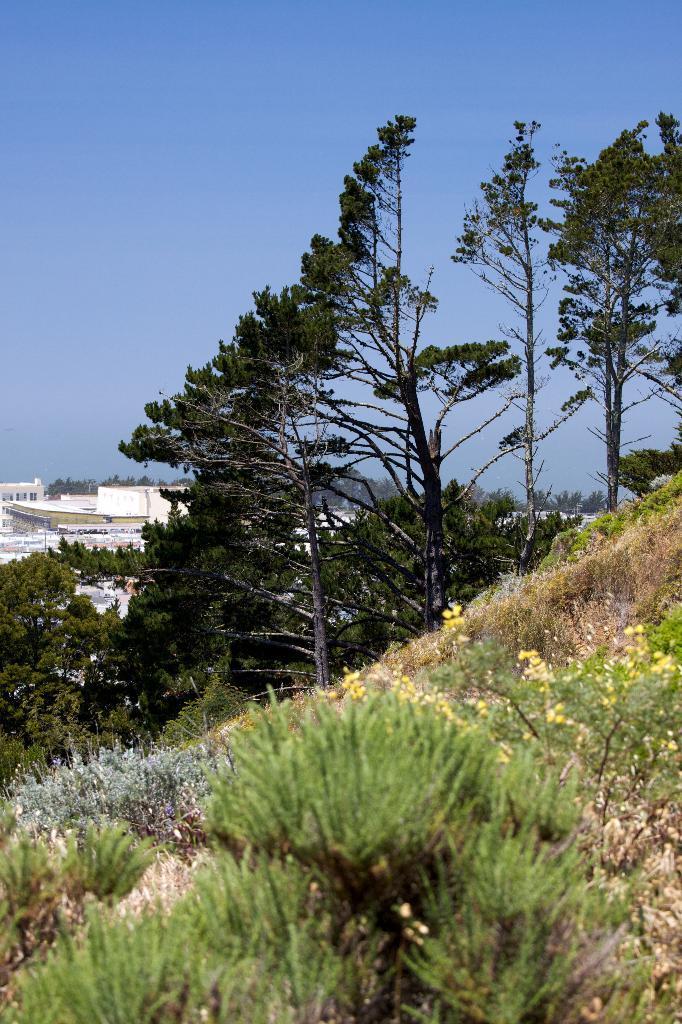In one or two sentences, can you explain what this image depicts? This picture is clicked outside. In the foreground we can see the plants and grass and trees. In the background we can see the sky and some houses. 